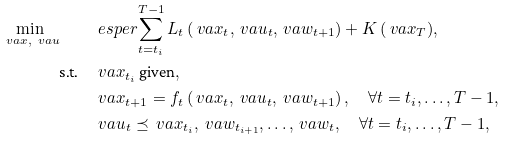<formula> <loc_0><loc_0><loc_500><loc_500>\min _ { \ v a { x } , \ v a { u } } \quad & \ e s p e r { \sum _ { t = t _ { i } } ^ { T - 1 } L _ { t } \left ( \ v a { x } _ { t } , \ v a { u } _ { t } , \ v a { w } _ { t + 1 } \right ) + K \left ( \ v a { x } _ { T } \right ) } , \\ \text {s.t.} \quad & \ v a { x } _ { t _ { i } } \text { given} , \\ & \ v a { x } _ { t + 1 } = f _ { t } \left ( \ v a { x } _ { t } , \ v a { u } _ { t } , \ v a { w } _ { t + 1 } \right ) , \quad \forall t = t _ { i } , \dots , T - 1 , \\ & \ v a { u } _ { t } \preceq \ v a { x } _ { t _ { i } } , \ v a { w } _ { t _ { i + 1 } } , \dots , \ v a { w } _ { t } , \quad \forall t = t _ { i } , \dots , T - 1 ,</formula> 